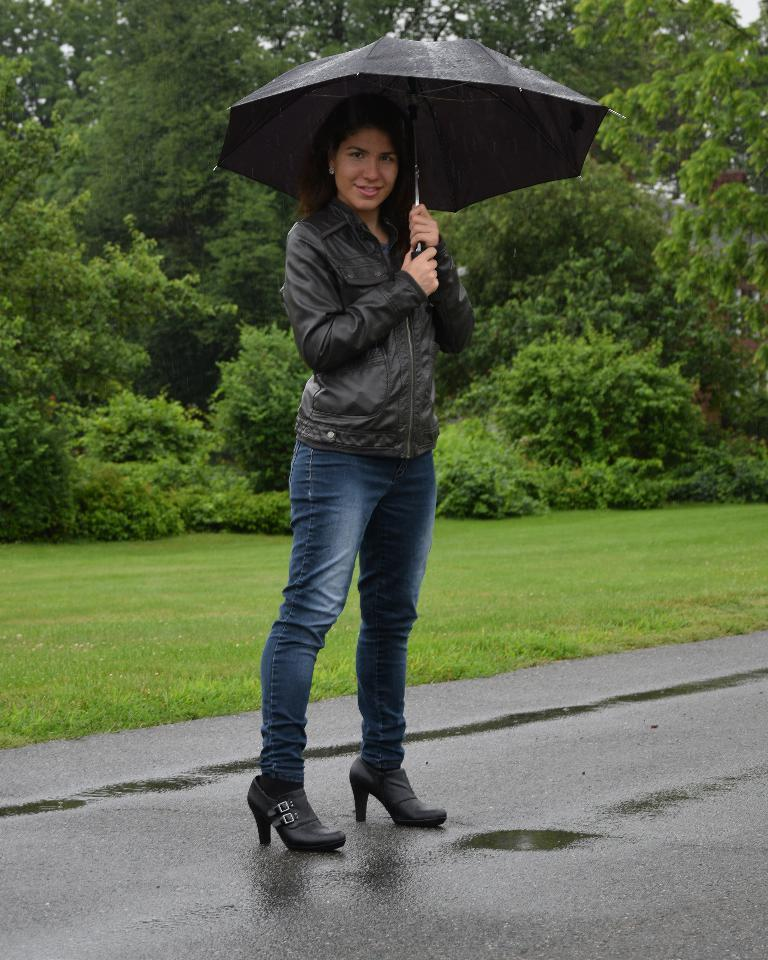Who is the main subject in the foreground of the image? There is a woman in the foreground of the image. What is the woman doing in the image? The woman is standing on the road. What object is the woman holding in the image? The woman is holding an umbrella. What type of vegetation can be seen in the background of the image? There are trees in the background of the image. What type of pie is the woman holding in the image? There is no pie present in the image; the woman is holding an umbrella. What type of protest is the woman participating in on the road? There is no protest present in the image; the woman is simply standing on the road with an umbrella. 